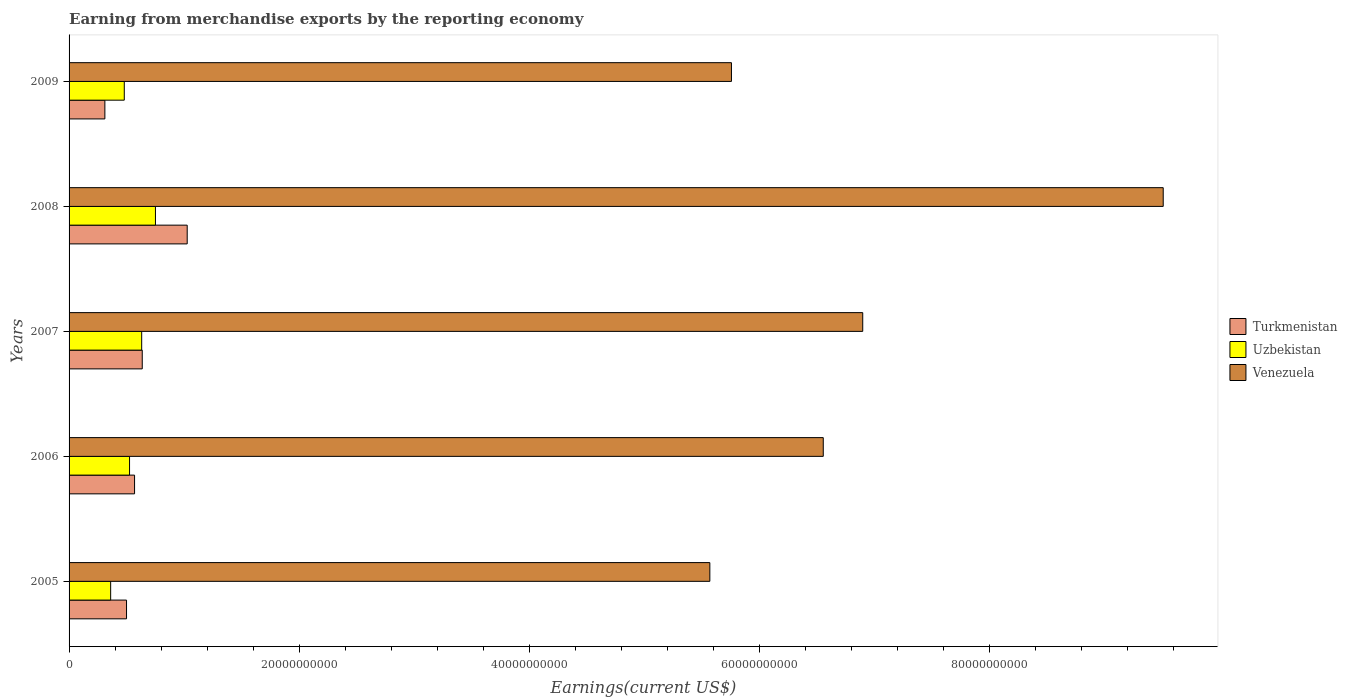How many groups of bars are there?
Keep it short and to the point. 5. Are the number of bars per tick equal to the number of legend labels?
Make the answer very short. Yes. Are the number of bars on each tick of the Y-axis equal?
Provide a succinct answer. Yes. How many bars are there on the 2nd tick from the top?
Provide a succinct answer. 3. How many bars are there on the 4th tick from the bottom?
Offer a terse response. 3. What is the amount earned from merchandise exports in Venezuela in 2009?
Your answer should be compact. 5.76e+1. Across all years, what is the maximum amount earned from merchandise exports in Turkmenistan?
Your answer should be very brief. 1.03e+1. Across all years, what is the minimum amount earned from merchandise exports in Turkmenistan?
Ensure brevity in your answer.  3.11e+09. In which year was the amount earned from merchandise exports in Uzbekistan maximum?
Provide a succinct answer. 2008. What is the total amount earned from merchandise exports in Venezuela in the graph?
Make the answer very short. 3.43e+11. What is the difference between the amount earned from merchandise exports in Uzbekistan in 2005 and that in 2009?
Keep it short and to the point. -1.19e+09. What is the difference between the amount earned from merchandise exports in Uzbekistan in 2006 and the amount earned from merchandise exports in Venezuela in 2009?
Your answer should be compact. -5.23e+1. What is the average amount earned from merchandise exports in Uzbekistan per year?
Provide a succinct answer. 5.50e+09. In the year 2006, what is the difference between the amount earned from merchandise exports in Uzbekistan and amount earned from merchandise exports in Venezuela?
Provide a succinct answer. -6.03e+1. What is the ratio of the amount earned from merchandise exports in Venezuela in 2008 to that in 2009?
Make the answer very short. 1.65. Is the difference between the amount earned from merchandise exports in Uzbekistan in 2008 and 2009 greater than the difference between the amount earned from merchandise exports in Venezuela in 2008 and 2009?
Provide a short and direct response. No. What is the difference between the highest and the second highest amount earned from merchandise exports in Turkmenistan?
Make the answer very short. 3.91e+09. What is the difference between the highest and the lowest amount earned from merchandise exports in Venezuela?
Your answer should be very brief. 3.94e+1. What does the 3rd bar from the top in 2006 represents?
Your answer should be compact. Turkmenistan. What does the 2nd bar from the bottom in 2005 represents?
Keep it short and to the point. Uzbekistan. How many bars are there?
Your response must be concise. 15. How many years are there in the graph?
Ensure brevity in your answer.  5. Does the graph contain any zero values?
Make the answer very short. No. How many legend labels are there?
Provide a short and direct response. 3. What is the title of the graph?
Give a very brief answer. Earning from merchandise exports by the reporting economy. What is the label or title of the X-axis?
Offer a very short reply. Earnings(current US$). What is the label or title of the Y-axis?
Provide a short and direct response. Years. What is the Earnings(current US$) in Turkmenistan in 2005?
Give a very brief answer. 5.00e+09. What is the Earnings(current US$) in Uzbekistan in 2005?
Make the answer very short. 3.62e+09. What is the Earnings(current US$) in Venezuela in 2005?
Offer a very short reply. 5.57e+1. What is the Earnings(current US$) of Turkmenistan in 2006?
Provide a short and direct response. 5.70e+09. What is the Earnings(current US$) in Uzbekistan in 2006?
Offer a terse response. 5.26e+09. What is the Earnings(current US$) in Venezuela in 2006?
Your answer should be very brief. 6.56e+1. What is the Earnings(current US$) of Turkmenistan in 2007?
Your response must be concise. 6.36e+09. What is the Earnings(current US$) in Uzbekistan in 2007?
Provide a short and direct response. 6.31e+09. What is the Earnings(current US$) in Venezuela in 2007?
Ensure brevity in your answer.  6.90e+1. What is the Earnings(current US$) of Turkmenistan in 2008?
Your answer should be compact. 1.03e+1. What is the Earnings(current US$) of Uzbekistan in 2008?
Provide a succinct answer. 7.51e+09. What is the Earnings(current US$) of Venezuela in 2008?
Provide a short and direct response. 9.51e+1. What is the Earnings(current US$) of Turkmenistan in 2009?
Offer a terse response. 3.11e+09. What is the Earnings(current US$) in Uzbekistan in 2009?
Your answer should be very brief. 4.80e+09. What is the Earnings(current US$) of Venezuela in 2009?
Offer a terse response. 5.76e+1. Across all years, what is the maximum Earnings(current US$) of Turkmenistan?
Keep it short and to the point. 1.03e+1. Across all years, what is the maximum Earnings(current US$) in Uzbekistan?
Your answer should be very brief. 7.51e+09. Across all years, what is the maximum Earnings(current US$) of Venezuela?
Make the answer very short. 9.51e+1. Across all years, what is the minimum Earnings(current US$) in Turkmenistan?
Your answer should be compact. 3.11e+09. Across all years, what is the minimum Earnings(current US$) of Uzbekistan?
Your answer should be compact. 3.62e+09. Across all years, what is the minimum Earnings(current US$) of Venezuela?
Ensure brevity in your answer.  5.57e+1. What is the total Earnings(current US$) of Turkmenistan in the graph?
Offer a very short reply. 3.04e+1. What is the total Earnings(current US$) in Uzbekistan in the graph?
Ensure brevity in your answer.  2.75e+1. What is the total Earnings(current US$) in Venezuela in the graph?
Make the answer very short. 3.43e+11. What is the difference between the Earnings(current US$) in Turkmenistan in 2005 and that in 2006?
Provide a short and direct response. -6.99e+08. What is the difference between the Earnings(current US$) in Uzbekistan in 2005 and that in 2006?
Provide a succinct answer. -1.64e+09. What is the difference between the Earnings(current US$) in Venezuela in 2005 and that in 2006?
Keep it short and to the point. -9.86e+09. What is the difference between the Earnings(current US$) in Turkmenistan in 2005 and that in 2007?
Your answer should be very brief. -1.37e+09. What is the difference between the Earnings(current US$) in Uzbekistan in 2005 and that in 2007?
Provide a short and direct response. -2.70e+09. What is the difference between the Earnings(current US$) of Venezuela in 2005 and that in 2007?
Provide a succinct answer. -1.33e+1. What is the difference between the Earnings(current US$) of Turkmenistan in 2005 and that in 2008?
Offer a very short reply. -5.28e+09. What is the difference between the Earnings(current US$) of Uzbekistan in 2005 and that in 2008?
Offer a terse response. -3.89e+09. What is the difference between the Earnings(current US$) of Venezuela in 2005 and that in 2008?
Make the answer very short. -3.94e+1. What is the difference between the Earnings(current US$) of Turkmenistan in 2005 and that in 2009?
Your answer should be very brief. 1.88e+09. What is the difference between the Earnings(current US$) in Uzbekistan in 2005 and that in 2009?
Your answer should be compact. -1.19e+09. What is the difference between the Earnings(current US$) in Venezuela in 2005 and that in 2009?
Offer a terse response. -1.88e+09. What is the difference between the Earnings(current US$) of Turkmenistan in 2006 and that in 2007?
Offer a terse response. -6.68e+08. What is the difference between the Earnings(current US$) in Uzbekistan in 2006 and that in 2007?
Provide a short and direct response. -1.06e+09. What is the difference between the Earnings(current US$) in Venezuela in 2006 and that in 2007?
Offer a terse response. -3.43e+09. What is the difference between the Earnings(current US$) in Turkmenistan in 2006 and that in 2008?
Keep it short and to the point. -4.58e+09. What is the difference between the Earnings(current US$) of Uzbekistan in 2006 and that in 2008?
Provide a short and direct response. -2.25e+09. What is the difference between the Earnings(current US$) of Venezuela in 2006 and that in 2008?
Provide a succinct answer. -2.96e+1. What is the difference between the Earnings(current US$) of Turkmenistan in 2006 and that in 2009?
Provide a succinct answer. 2.58e+09. What is the difference between the Earnings(current US$) in Uzbekistan in 2006 and that in 2009?
Your answer should be compact. 4.57e+08. What is the difference between the Earnings(current US$) in Venezuela in 2006 and that in 2009?
Make the answer very short. 7.98e+09. What is the difference between the Earnings(current US$) of Turkmenistan in 2007 and that in 2008?
Your answer should be very brief. -3.91e+09. What is the difference between the Earnings(current US$) in Uzbekistan in 2007 and that in 2008?
Ensure brevity in your answer.  -1.20e+09. What is the difference between the Earnings(current US$) of Venezuela in 2007 and that in 2008?
Your answer should be compact. -2.61e+1. What is the difference between the Earnings(current US$) in Turkmenistan in 2007 and that in 2009?
Give a very brief answer. 3.25e+09. What is the difference between the Earnings(current US$) of Uzbekistan in 2007 and that in 2009?
Your answer should be very brief. 1.51e+09. What is the difference between the Earnings(current US$) of Venezuela in 2007 and that in 2009?
Offer a very short reply. 1.14e+1. What is the difference between the Earnings(current US$) in Turkmenistan in 2008 and that in 2009?
Your response must be concise. 7.16e+09. What is the difference between the Earnings(current US$) in Uzbekistan in 2008 and that in 2009?
Make the answer very short. 2.71e+09. What is the difference between the Earnings(current US$) of Venezuela in 2008 and that in 2009?
Ensure brevity in your answer.  3.75e+1. What is the difference between the Earnings(current US$) of Turkmenistan in 2005 and the Earnings(current US$) of Uzbekistan in 2006?
Make the answer very short. -2.62e+08. What is the difference between the Earnings(current US$) of Turkmenistan in 2005 and the Earnings(current US$) of Venezuela in 2006?
Provide a short and direct response. -6.06e+1. What is the difference between the Earnings(current US$) in Uzbekistan in 2005 and the Earnings(current US$) in Venezuela in 2006?
Your response must be concise. -6.20e+1. What is the difference between the Earnings(current US$) of Turkmenistan in 2005 and the Earnings(current US$) of Uzbekistan in 2007?
Offer a very short reply. -1.32e+09. What is the difference between the Earnings(current US$) in Turkmenistan in 2005 and the Earnings(current US$) in Venezuela in 2007?
Give a very brief answer. -6.40e+1. What is the difference between the Earnings(current US$) in Uzbekistan in 2005 and the Earnings(current US$) in Venezuela in 2007?
Offer a very short reply. -6.54e+1. What is the difference between the Earnings(current US$) of Turkmenistan in 2005 and the Earnings(current US$) of Uzbekistan in 2008?
Keep it short and to the point. -2.51e+09. What is the difference between the Earnings(current US$) in Turkmenistan in 2005 and the Earnings(current US$) in Venezuela in 2008?
Your answer should be compact. -9.01e+1. What is the difference between the Earnings(current US$) of Uzbekistan in 2005 and the Earnings(current US$) of Venezuela in 2008?
Keep it short and to the point. -9.15e+1. What is the difference between the Earnings(current US$) in Turkmenistan in 2005 and the Earnings(current US$) in Uzbekistan in 2009?
Make the answer very short. 1.95e+08. What is the difference between the Earnings(current US$) in Turkmenistan in 2005 and the Earnings(current US$) in Venezuela in 2009?
Keep it short and to the point. -5.26e+1. What is the difference between the Earnings(current US$) of Uzbekistan in 2005 and the Earnings(current US$) of Venezuela in 2009?
Make the answer very short. -5.40e+1. What is the difference between the Earnings(current US$) in Turkmenistan in 2006 and the Earnings(current US$) in Uzbekistan in 2007?
Provide a short and direct response. -6.19e+08. What is the difference between the Earnings(current US$) of Turkmenistan in 2006 and the Earnings(current US$) of Venezuela in 2007?
Give a very brief answer. -6.33e+1. What is the difference between the Earnings(current US$) in Uzbekistan in 2006 and the Earnings(current US$) in Venezuela in 2007?
Give a very brief answer. -6.38e+1. What is the difference between the Earnings(current US$) in Turkmenistan in 2006 and the Earnings(current US$) in Uzbekistan in 2008?
Your response must be concise. -1.82e+09. What is the difference between the Earnings(current US$) of Turkmenistan in 2006 and the Earnings(current US$) of Venezuela in 2008?
Provide a short and direct response. -8.94e+1. What is the difference between the Earnings(current US$) of Uzbekistan in 2006 and the Earnings(current US$) of Venezuela in 2008?
Your response must be concise. -8.99e+1. What is the difference between the Earnings(current US$) of Turkmenistan in 2006 and the Earnings(current US$) of Uzbekistan in 2009?
Give a very brief answer. 8.94e+08. What is the difference between the Earnings(current US$) of Turkmenistan in 2006 and the Earnings(current US$) of Venezuela in 2009?
Offer a terse response. -5.19e+1. What is the difference between the Earnings(current US$) in Uzbekistan in 2006 and the Earnings(current US$) in Venezuela in 2009?
Offer a terse response. -5.23e+1. What is the difference between the Earnings(current US$) of Turkmenistan in 2007 and the Earnings(current US$) of Uzbekistan in 2008?
Give a very brief answer. -1.15e+09. What is the difference between the Earnings(current US$) in Turkmenistan in 2007 and the Earnings(current US$) in Venezuela in 2008?
Give a very brief answer. -8.88e+1. What is the difference between the Earnings(current US$) in Uzbekistan in 2007 and the Earnings(current US$) in Venezuela in 2008?
Make the answer very short. -8.88e+1. What is the difference between the Earnings(current US$) in Turkmenistan in 2007 and the Earnings(current US$) in Uzbekistan in 2009?
Keep it short and to the point. 1.56e+09. What is the difference between the Earnings(current US$) of Turkmenistan in 2007 and the Earnings(current US$) of Venezuela in 2009?
Offer a terse response. -5.12e+1. What is the difference between the Earnings(current US$) of Uzbekistan in 2007 and the Earnings(current US$) of Venezuela in 2009?
Ensure brevity in your answer.  -5.13e+1. What is the difference between the Earnings(current US$) of Turkmenistan in 2008 and the Earnings(current US$) of Uzbekistan in 2009?
Ensure brevity in your answer.  5.47e+09. What is the difference between the Earnings(current US$) in Turkmenistan in 2008 and the Earnings(current US$) in Venezuela in 2009?
Provide a succinct answer. -4.73e+1. What is the difference between the Earnings(current US$) of Uzbekistan in 2008 and the Earnings(current US$) of Venezuela in 2009?
Ensure brevity in your answer.  -5.01e+1. What is the average Earnings(current US$) in Turkmenistan per year?
Make the answer very short. 6.09e+09. What is the average Earnings(current US$) in Uzbekistan per year?
Make the answer very short. 5.50e+09. What is the average Earnings(current US$) of Venezuela per year?
Keep it short and to the point. 6.86e+1. In the year 2005, what is the difference between the Earnings(current US$) in Turkmenistan and Earnings(current US$) in Uzbekistan?
Your answer should be compact. 1.38e+09. In the year 2005, what is the difference between the Earnings(current US$) in Turkmenistan and Earnings(current US$) in Venezuela?
Offer a very short reply. -5.07e+1. In the year 2005, what is the difference between the Earnings(current US$) of Uzbekistan and Earnings(current US$) of Venezuela?
Ensure brevity in your answer.  -5.21e+1. In the year 2006, what is the difference between the Earnings(current US$) of Turkmenistan and Earnings(current US$) of Uzbekistan?
Keep it short and to the point. 4.37e+08. In the year 2006, what is the difference between the Earnings(current US$) of Turkmenistan and Earnings(current US$) of Venezuela?
Your answer should be very brief. -5.99e+1. In the year 2006, what is the difference between the Earnings(current US$) of Uzbekistan and Earnings(current US$) of Venezuela?
Your answer should be compact. -6.03e+1. In the year 2007, what is the difference between the Earnings(current US$) of Turkmenistan and Earnings(current US$) of Uzbekistan?
Keep it short and to the point. 4.86e+07. In the year 2007, what is the difference between the Earnings(current US$) in Turkmenistan and Earnings(current US$) in Venezuela?
Make the answer very short. -6.26e+1. In the year 2007, what is the difference between the Earnings(current US$) of Uzbekistan and Earnings(current US$) of Venezuela?
Ensure brevity in your answer.  -6.27e+1. In the year 2008, what is the difference between the Earnings(current US$) of Turkmenistan and Earnings(current US$) of Uzbekistan?
Ensure brevity in your answer.  2.76e+09. In the year 2008, what is the difference between the Earnings(current US$) in Turkmenistan and Earnings(current US$) in Venezuela?
Ensure brevity in your answer.  -8.49e+1. In the year 2008, what is the difference between the Earnings(current US$) in Uzbekistan and Earnings(current US$) in Venezuela?
Keep it short and to the point. -8.76e+1. In the year 2009, what is the difference between the Earnings(current US$) in Turkmenistan and Earnings(current US$) in Uzbekistan?
Give a very brief answer. -1.69e+09. In the year 2009, what is the difference between the Earnings(current US$) of Turkmenistan and Earnings(current US$) of Venezuela?
Provide a succinct answer. -5.45e+1. In the year 2009, what is the difference between the Earnings(current US$) of Uzbekistan and Earnings(current US$) of Venezuela?
Keep it short and to the point. -5.28e+1. What is the ratio of the Earnings(current US$) of Turkmenistan in 2005 to that in 2006?
Keep it short and to the point. 0.88. What is the ratio of the Earnings(current US$) in Uzbekistan in 2005 to that in 2006?
Keep it short and to the point. 0.69. What is the ratio of the Earnings(current US$) of Venezuela in 2005 to that in 2006?
Your answer should be very brief. 0.85. What is the ratio of the Earnings(current US$) of Turkmenistan in 2005 to that in 2007?
Your answer should be very brief. 0.79. What is the ratio of the Earnings(current US$) of Uzbekistan in 2005 to that in 2007?
Your response must be concise. 0.57. What is the ratio of the Earnings(current US$) in Venezuela in 2005 to that in 2007?
Keep it short and to the point. 0.81. What is the ratio of the Earnings(current US$) of Turkmenistan in 2005 to that in 2008?
Make the answer very short. 0.49. What is the ratio of the Earnings(current US$) of Uzbekistan in 2005 to that in 2008?
Offer a terse response. 0.48. What is the ratio of the Earnings(current US$) in Venezuela in 2005 to that in 2008?
Ensure brevity in your answer.  0.59. What is the ratio of the Earnings(current US$) of Turkmenistan in 2005 to that in 2009?
Ensure brevity in your answer.  1.6. What is the ratio of the Earnings(current US$) of Uzbekistan in 2005 to that in 2009?
Offer a terse response. 0.75. What is the ratio of the Earnings(current US$) in Venezuela in 2005 to that in 2009?
Your answer should be very brief. 0.97. What is the ratio of the Earnings(current US$) in Turkmenistan in 2006 to that in 2007?
Make the answer very short. 0.9. What is the ratio of the Earnings(current US$) in Uzbekistan in 2006 to that in 2007?
Your response must be concise. 0.83. What is the ratio of the Earnings(current US$) of Venezuela in 2006 to that in 2007?
Give a very brief answer. 0.95. What is the ratio of the Earnings(current US$) of Turkmenistan in 2006 to that in 2008?
Provide a succinct answer. 0.55. What is the ratio of the Earnings(current US$) of Venezuela in 2006 to that in 2008?
Give a very brief answer. 0.69. What is the ratio of the Earnings(current US$) in Turkmenistan in 2006 to that in 2009?
Offer a terse response. 1.83. What is the ratio of the Earnings(current US$) in Uzbekistan in 2006 to that in 2009?
Offer a terse response. 1.1. What is the ratio of the Earnings(current US$) of Venezuela in 2006 to that in 2009?
Offer a terse response. 1.14. What is the ratio of the Earnings(current US$) in Turkmenistan in 2007 to that in 2008?
Your response must be concise. 0.62. What is the ratio of the Earnings(current US$) in Uzbekistan in 2007 to that in 2008?
Your answer should be compact. 0.84. What is the ratio of the Earnings(current US$) in Venezuela in 2007 to that in 2008?
Give a very brief answer. 0.73. What is the ratio of the Earnings(current US$) of Turkmenistan in 2007 to that in 2009?
Provide a short and direct response. 2.04. What is the ratio of the Earnings(current US$) in Uzbekistan in 2007 to that in 2009?
Offer a very short reply. 1.32. What is the ratio of the Earnings(current US$) in Venezuela in 2007 to that in 2009?
Keep it short and to the point. 1.2. What is the ratio of the Earnings(current US$) in Turkmenistan in 2008 to that in 2009?
Offer a very short reply. 3.3. What is the ratio of the Earnings(current US$) of Uzbekistan in 2008 to that in 2009?
Keep it short and to the point. 1.56. What is the ratio of the Earnings(current US$) of Venezuela in 2008 to that in 2009?
Provide a short and direct response. 1.65. What is the difference between the highest and the second highest Earnings(current US$) in Turkmenistan?
Your answer should be very brief. 3.91e+09. What is the difference between the highest and the second highest Earnings(current US$) in Uzbekistan?
Your response must be concise. 1.20e+09. What is the difference between the highest and the second highest Earnings(current US$) in Venezuela?
Provide a succinct answer. 2.61e+1. What is the difference between the highest and the lowest Earnings(current US$) of Turkmenistan?
Your answer should be compact. 7.16e+09. What is the difference between the highest and the lowest Earnings(current US$) of Uzbekistan?
Provide a succinct answer. 3.89e+09. What is the difference between the highest and the lowest Earnings(current US$) in Venezuela?
Ensure brevity in your answer.  3.94e+1. 